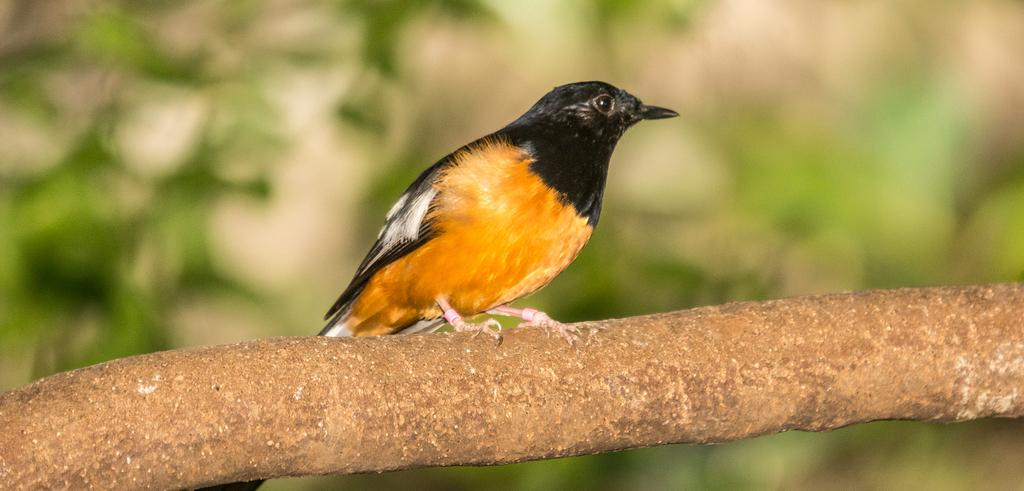What is the bird perched on in the image? The bird is perched on an object that resembles a tree stem in the image. What type of vegetation can be seen in the background? There are green leaves visible in the background. How would you describe the appearance of the background in the image? The background of the image is blurred. What type of drink is the bird holding in its beak in the image? There is no drink present in the image; the bird is perched on an object that resembles a tree stem. Can you see any marks or symbols on the leaves in the background? There are no marks or symbols visible on the leaves in the background; only green leaves are present. 